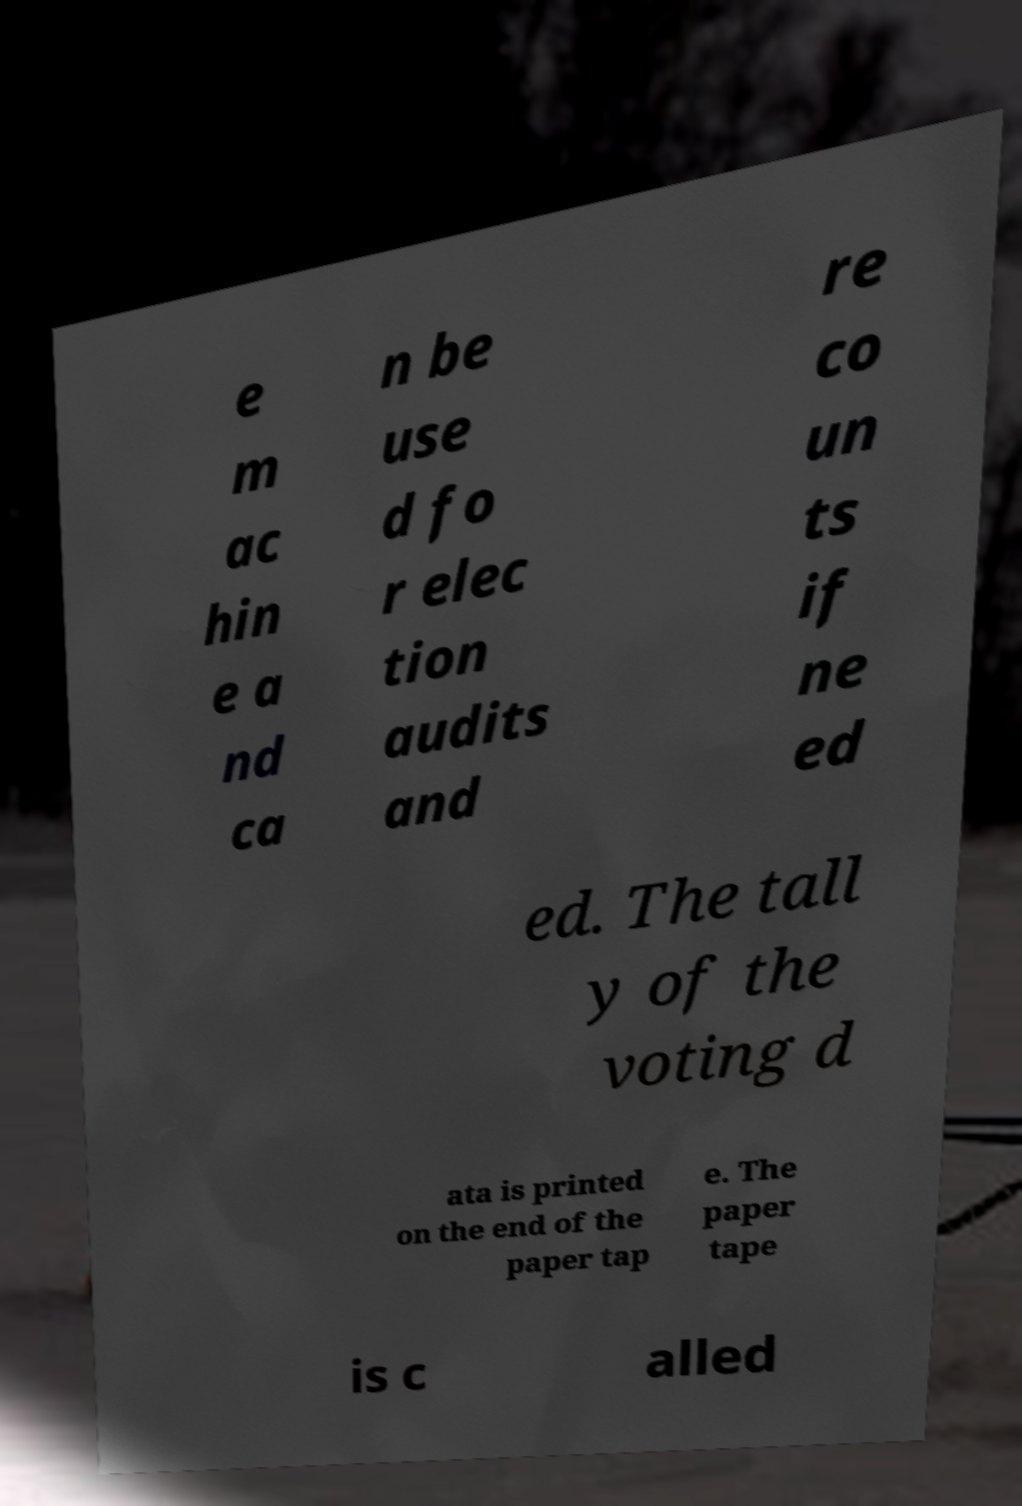I need the written content from this picture converted into text. Can you do that? e m ac hin e a nd ca n be use d fo r elec tion audits and re co un ts if ne ed ed. The tall y of the voting d ata is printed on the end of the paper tap e. The paper tape is c alled 